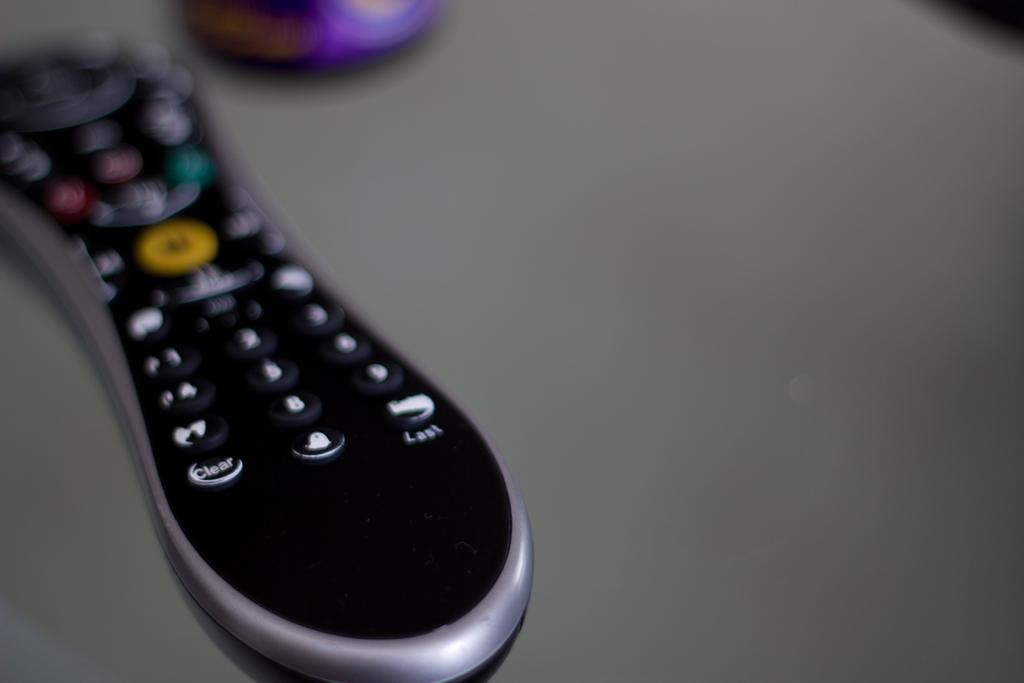Provide a one-sentence caption for the provided image. Black remote controller with the "Clear" button on the bottom left. 